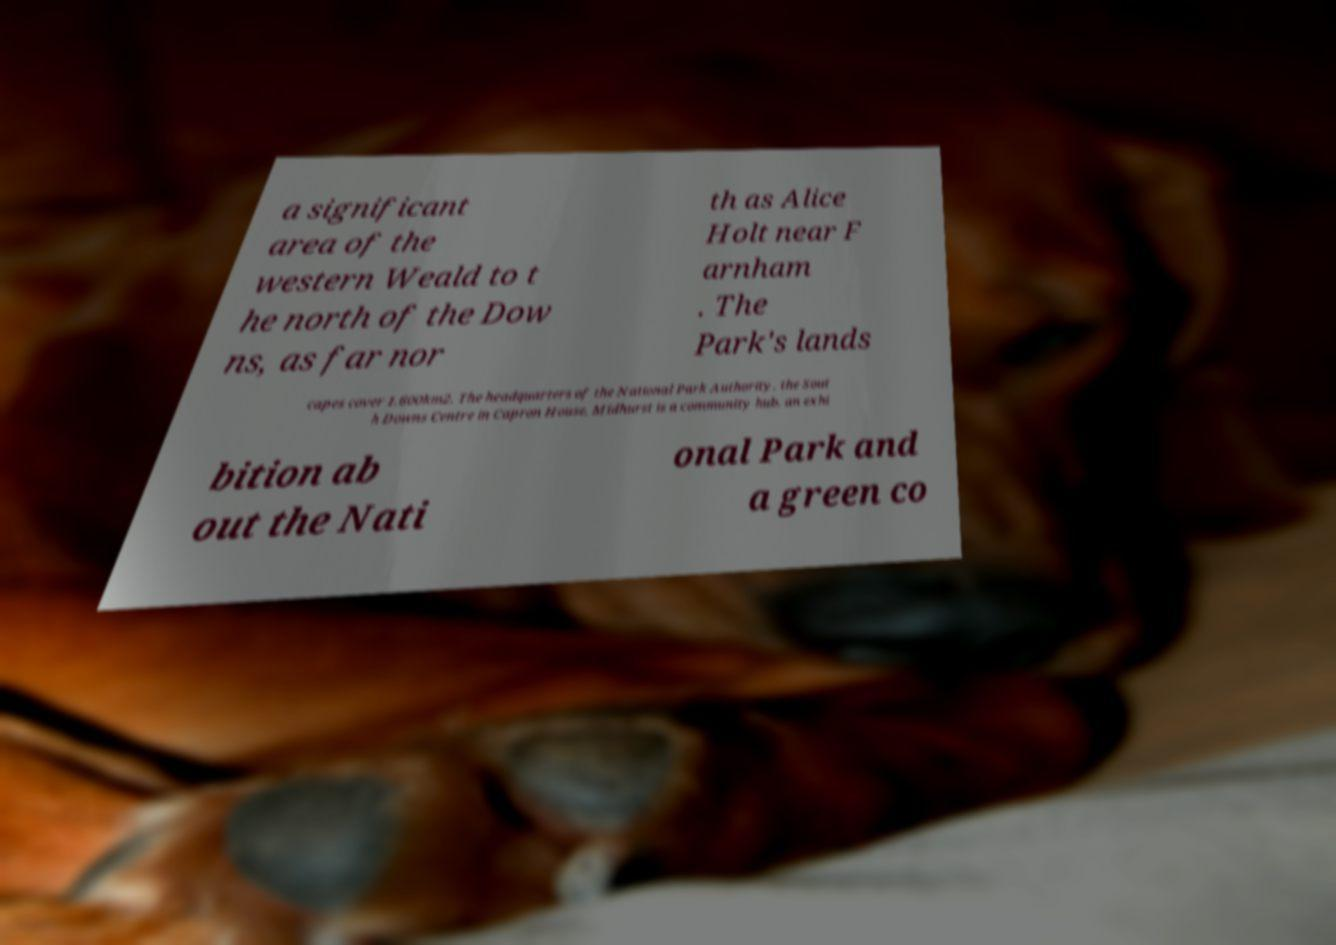Can you accurately transcribe the text from the provided image for me? a significant area of the western Weald to t he north of the Dow ns, as far nor th as Alice Holt near F arnham . The Park's lands capes cover 1,600km2. The headquarters of the National Park Authority, the Sout h Downs Centre in Capron House, Midhurst is a community hub, an exhi bition ab out the Nati onal Park and a green co 